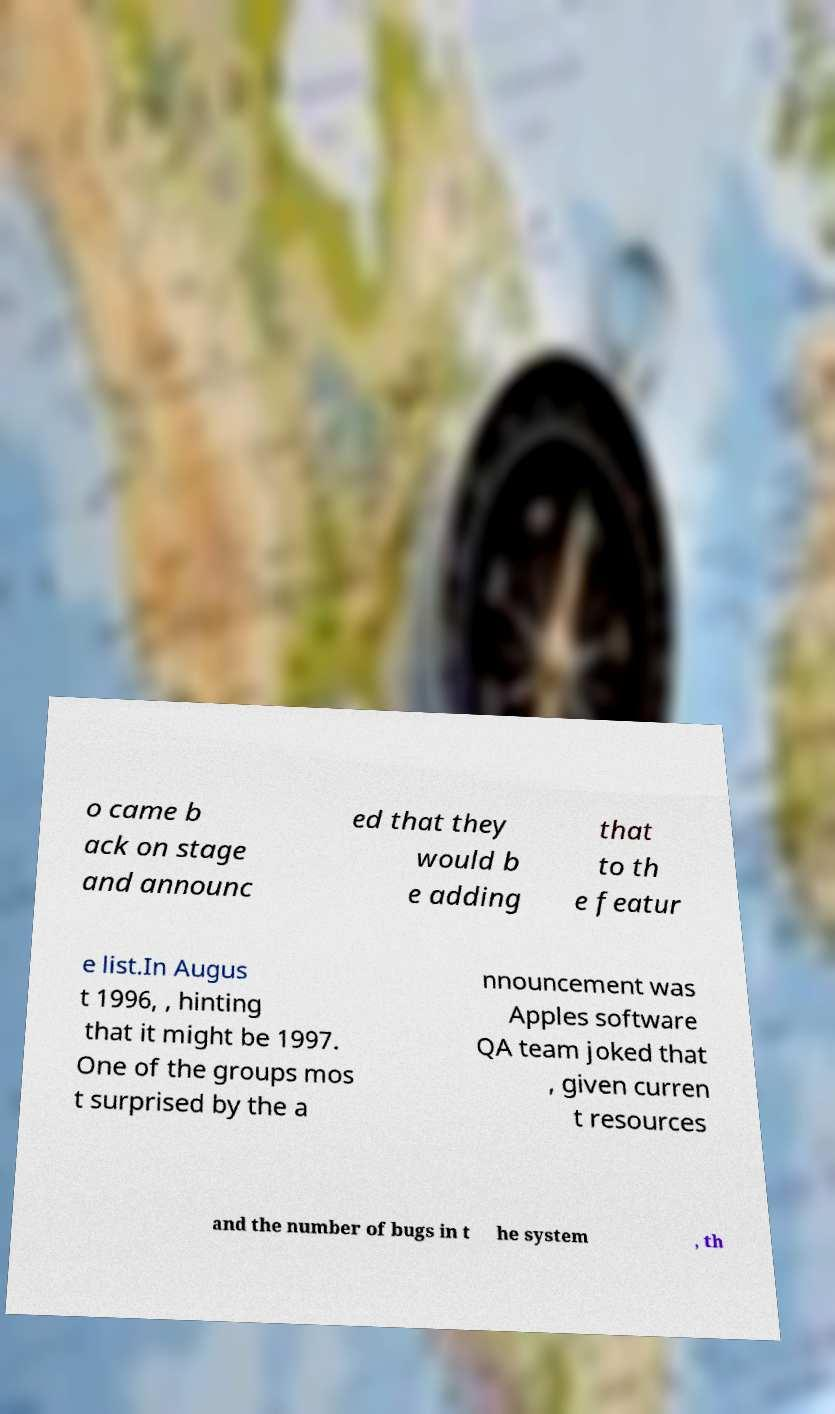I need the written content from this picture converted into text. Can you do that? o came b ack on stage and announc ed that they would b e adding that to th e featur e list.In Augus t 1996, , hinting that it might be 1997. One of the groups mos t surprised by the a nnouncement was Apples software QA team joked that , given curren t resources and the number of bugs in t he system , th 